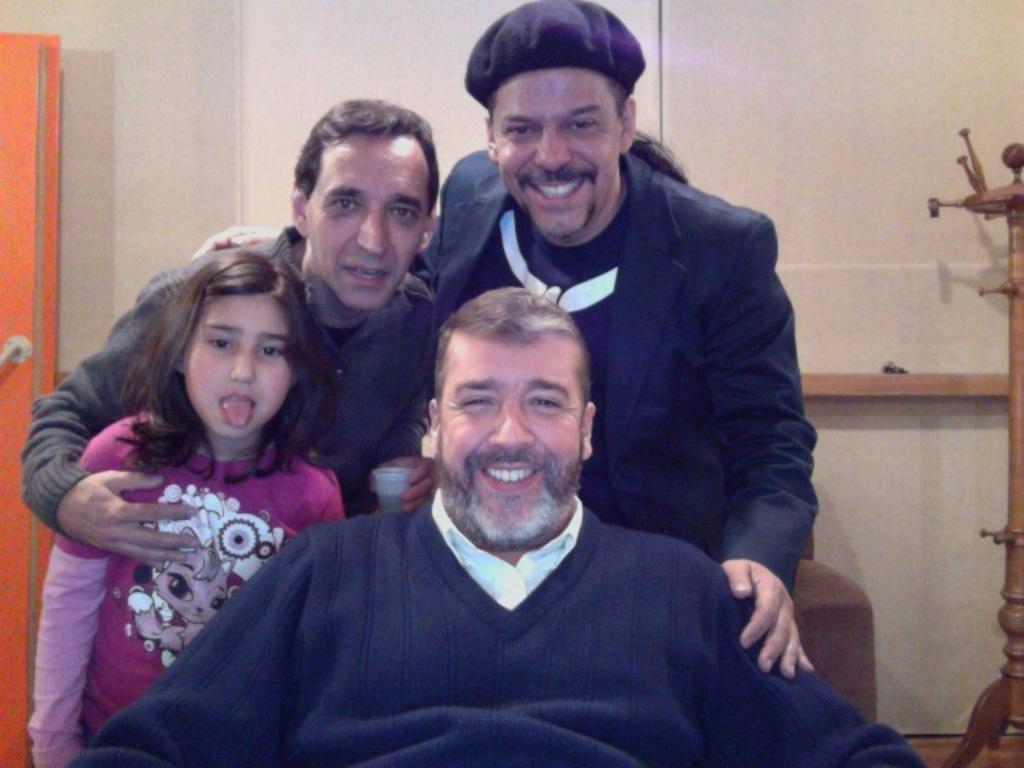How many people are in the image? There are a few people in the image. What are the people in the image doing? The people are posing for the camera. What expressions do the people have on their faces? The people have smiles on their faces. Can you tell me how many giraffes are in the image? There are no giraffes present in the image. What type of memory does the person in the image have? The image does not provide information about the person's memory. 